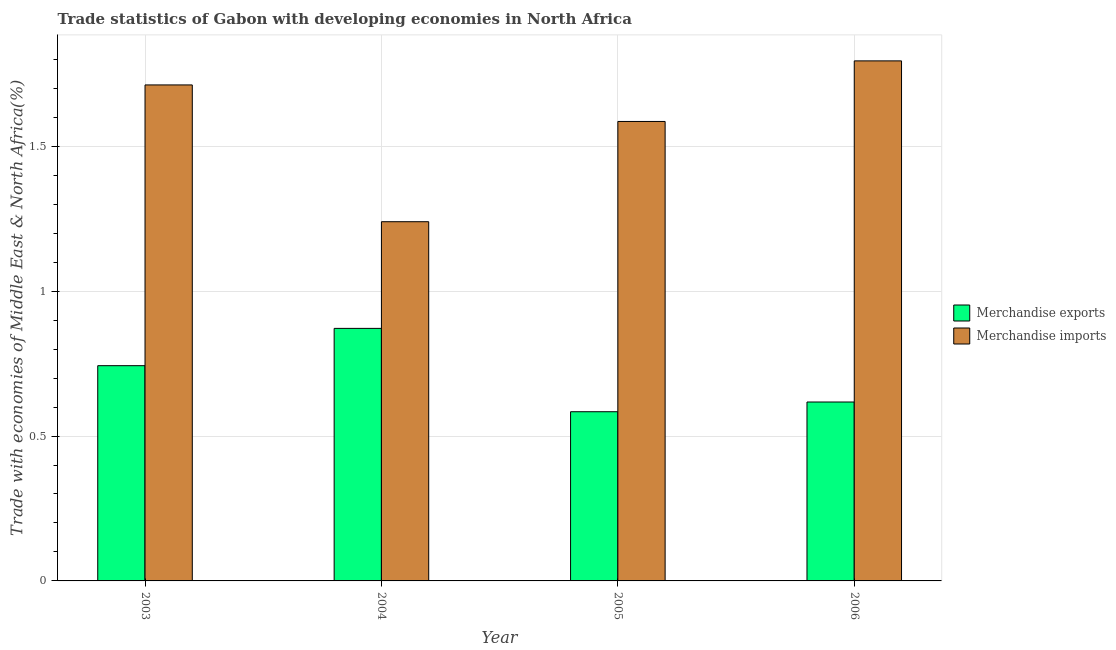How many different coloured bars are there?
Your response must be concise. 2. Are the number of bars per tick equal to the number of legend labels?
Your answer should be compact. Yes. How many bars are there on the 4th tick from the left?
Offer a very short reply. 2. In how many cases, is the number of bars for a given year not equal to the number of legend labels?
Provide a short and direct response. 0. What is the merchandise exports in 2004?
Offer a very short reply. 0.87. Across all years, what is the maximum merchandise imports?
Your answer should be compact. 1.79. Across all years, what is the minimum merchandise exports?
Your response must be concise. 0.58. In which year was the merchandise exports minimum?
Your answer should be compact. 2005. What is the total merchandise exports in the graph?
Provide a succinct answer. 2.82. What is the difference between the merchandise exports in 2004 and that in 2006?
Offer a very short reply. 0.25. What is the difference between the merchandise imports in 2003 and the merchandise exports in 2005?
Your response must be concise. 0.13. What is the average merchandise exports per year?
Keep it short and to the point. 0.7. In the year 2006, what is the difference between the merchandise imports and merchandise exports?
Your answer should be very brief. 0. In how many years, is the merchandise exports greater than 1.4 %?
Your answer should be very brief. 0. What is the ratio of the merchandise imports in 2003 to that in 2006?
Your answer should be very brief. 0.95. Is the difference between the merchandise imports in 2005 and 2006 greater than the difference between the merchandise exports in 2005 and 2006?
Your response must be concise. No. What is the difference between the highest and the second highest merchandise imports?
Ensure brevity in your answer.  0.08. What is the difference between the highest and the lowest merchandise imports?
Give a very brief answer. 0.56. How many years are there in the graph?
Your response must be concise. 4. What is the difference between two consecutive major ticks on the Y-axis?
Give a very brief answer. 0.5. Are the values on the major ticks of Y-axis written in scientific E-notation?
Your answer should be compact. No. Does the graph contain any zero values?
Your response must be concise. No. Does the graph contain grids?
Give a very brief answer. Yes. Where does the legend appear in the graph?
Offer a very short reply. Center right. How many legend labels are there?
Keep it short and to the point. 2. How are the legend labels stacked?
Provide a succinct answer. Vertical. What is the title of the graph?
Provide a succinct answer. Trade statistics of Gabon with developing economies in North Africa. Does "Net National savings" appear as one of the legend labels in the graph?
Offer a terse response. No. What is the label or title of the Y-axis?
Your answer should be compact. Trade with economies of Middle East & North Africa(%). What is the Trade with economies of Middle East & North Africa(%) of Merchandise exports in 2003?
Provide a short and direct response. 0.74. What is the Trade with economies of Middle East & North Africa(%) in Merchandise imports in 2003?
Provide a succinct answer. 1.71. What is the Trade with economies of Middle East & North Africa(%) of Merchandise exports in 2004?
Your response must be concise. 0.87. What is the Trade with economies of Middle East & North Africa(%) of Merchandise imports in 2004?
Provide a short and direct response. 1.24. What is the Trade with economies of Middle East & North Africa(%) in Merchandise exports in 2005?
Make the answer very short. 0.58. What is the Trade with economies of Middle East & North Africa(%) in Merchandise imports in 2005?
Your answer should be very brief. 1.59. What is the Trade with economies of Middle East & North Africa(%) of Merchandise exports in 2006?
Offer a very short reply. 0.62. What is the Trade with economies of Middle East & North Africa(%) of Merchandise imports in 2006?
Offer a very short reply. 1.79. Across all years, what is the maximum Trade with economies of Middle East & North Africa(%) in Merchandise exports?
Provide a short and direct response. 0.87. Across all years, what is the maximum Trade with economies of Middle East & North Africa(%) of Merchandise imports?
Give a very brief answer. 1.79. Across all years, what is the minimum Trade with economies of Middle East & North Africa(%) in Merchandise exports?
Keep it short and to the point. 0.58. Across all years, what is the minimum Trade with economies of Middle East & North Africa(%) of Merchandise imports?
Keep it short and to the point. 1.24. What is the total Trade with economies of Middle East & North Africa(%) of Merchandise exports in the graph?
Provide a short and direct response. 2.82. What is the total Trade with economies of Middle East & North Africa(%) of Merchandise imports in the graph?
Give a very brief answer. 6.33. What is the difference between the Trade with economies of Middle East & North Africa(%) in Merchandise exports in 2003 and that in 2004?
Ensure brevity in your answer.  -0.13. What is the difference between the Trade with economies of Middle East & North Africa(%) in Merchandise imports in 2003 and that in 2004?
Your response must be concise. 0.47. What is the difference between the Trade with economies of Middle East & North Africa(%) of Merchandise exports in 2003 and that in 2005?
Keep it short and to the point. 0.16. What is the difference between the Trade with economies of Middle East & North Africa(%) of Merchandise imports in 2003 and that in 2005?
Give a very brief answer. 0.13. What is the difference between the Trade with economies of Middle East & North Africa(%) of Merchandise exports in 2003 and that in 2006?
Offer a very short reply. 0.13. What is the difference between the Trade with economies of Middle East & North Africa(%) in Merchandise imports in 2003 and that in 2006?
Ensure brevity in your answer.  -0.08. What is the difference between the Trade with economies of Middle East & North Africa(%) in Merchandise exports in 2004 and that in 2005?
Ensure brevity in your answer.  0.29. What is the difference between the Trade with economies of Middle East & North Africa(%) of Merchandise imports in 2004 and that in 2005?
Provide a succinct answer. -0.35. What is the difference between the Trade with economies of Middle East & North Africa(%) in Merchandise exports in 2004 and that in 2006?
Your answer should be very brief. 0.25. What is the difference between the Trade with economies of Middle East & North Africa(%) of Merchandise imports in 2004 and that in 2006?
Provide a short and direct response. -0.56. What is the difference between the Trade with economies of Middle East & North Africa(%) of Merchandise exports in 2005 and that in 2006?
Offer a very short reply. -0.03. What is the difference between the Trade with economies of Middle East & North Africa(%) in Merchandise imports in 2005 and that in 2006?
Provide a succinct answer. -0.21. What is the difference between the Trade with economies of Middle East & North Africa(%) in Merchandise exports in 2003 and the Trade with economies of Middle East & North Africa(%) in Merchandise imports in 2004?
Give a very brief answer. -0.5. What is the difference between the Trade with economies of Middle East & North Africa(%) of Merchandise exports in 2003 and the Trade with economies of Middle East & North Africa(%) of Merchandise imports in 2005?
Keep it short and to the point. -0.84. What is the difference between the Trade with economies of Middle East & North Africa(%) of Merchandise exports in 2003 and the Trade with economies of Middle East & North Africa(%) of Merchandise imports in 2006?
Your response must be concise. -1.05. What is the difference between the Trade with economies of Middle East & North Africa(%) of Merchandise exports in 2004 and the Trade with economies of Middle East & North Africa(%) of Merchandise imports in 2005?
Your response must be concise. -0.71. What is the difference between the Trade with economies of Middle East & North Africa(%) in Merchandise exports in 2004 and the Trade with economies of Middle East & North Africa(%) in Merchandise imports in 2006?
Keep it short and to the point. -0.92. What is the difference between the Trade with economies of Middle East & North Africa(%) of Merchandise exports in 2005 and the Trade with economies of Middle East & North Africa(%) of Merchandise imports in 2006?
Offer a very short reply. -1.21. What is the average Trade with economies of Middle East & North Africa(%) of Merchandise exports per year?
Offer a very short reply. 0.7. What is the average Trade with economies of Middle East & North Africa(%) in Merchandise imports per year?
Offer a very short reply. 1.58. In the year 2003, what is the difference between the Trade with economies of Middle East & North Africa(%) in Merchandise exports and Trade with economies of Middle East & North Africa(%) in Merchandise imports?
Ensure brevity in your answer.  -0.97. In the year 2004, what is the difference between the Trade with economies of Middle East & North Africa(%) in Merchandise exports and Trade with economies of Middle East & North Africa(%) in Merchandise imports?
Your response must be concise. -0.37. In the year 2005, what is the difference between the Trade with economies of Middle East & North Africa(%) of Merchandise exports and Trade with economies of Middle East & North Africa(%) of Merchandise imports?
Make the answer very short. -1. In the year 2006, what is the difference between the Trade with economies of Middle East & North Africa(%) of Merchandise exports and Trade with economies of Middle East & North Africa(%) of Merchandise imports?
Offer a terse response. -1.18. What is the ratio of the Trade with economies of Middle East & North Africa(%) in Merchandise exports in 2003 to that in 2004?
Your answer should be very brief. 0.85. What is the ratio of the Trade with economies of Middle East & North Africa(%) of Merchandise imports in 2003 to that in 2004?
Provide a short and direct response. 1.38. What is the ratio of the Trade with economies of Middle East & North Africa(%) in Merchandise exports in 2003 to that in 2005?
Ensure brevity in your answer.  1.27. What is the ratio of the Trade with economies of Middle East & North Africa(%) in Merchandise imports in 2003 to that in 2005?
Your response must be concise. 1.08. What is the ratio of the Trade with economies of Middle East & North Africa(%) of Merchandise exports in 2003 to that in 2006?
Provide a succinct answer. 1.2. What is the ratio of the Trade with economies of Middle East & North Africa(%) in Merchandise imports in 2003 to that in 2006?
Provide a succinct answer. 0.95. What is the ratio of the Trade with economies of Middle East & North Africa(%) in Merchandise exports in 2004 to that in 2005?
Provide a short and direct response. 1.49. What is the ratio of the Trade with economies of Middle East & North Africa(%) of Merchandise imports in 2004 to that in 2005?
Provide a short and direct response. 0.78. What is the ratio of the Trade with economies of Middle East & North Africa(%) of Merchandise exports in 2004 to that in 2006?
Give a very brief answer. 1.41. What is the ratio of the Trade with economies of Middle East & North Africa(%) in Merchandise imports in 2004 to that in 2006?
Your answer should be compact. 0.69. What is the ratio of the Trade with economies of Middle East & North Africa(%) in Merchandise exports in 2005 to that in 2006?
Ensure brevity in your answer.  0.95. What is the ratio of the Trade with economies of Middle East & North Africa(%) in Merchandise imports in 2005 to that in 2006?
Give a very brief answer. 0.88. What is the difference between the highest and the second highest Trade with economies of Middle East & North Africa(%) of Merchandise exports?
Make the answer very short. 0.13. What is the difference between the highest and the second highest Trade with economies of Middle East & North Africa(%) in Merchandise imports?
Give a very brief answer. 0.08. What is the difference between the highest and the lowest Trade with economies of Middle East & North Africa(%) in Merchandise exports?
Give a very brief answer. 0.29. What is the difference between the highest and the lowest Trade with economies of Middle East & North Africa(%) of Merchandise imports?
Your response must be concise. 0.56. 